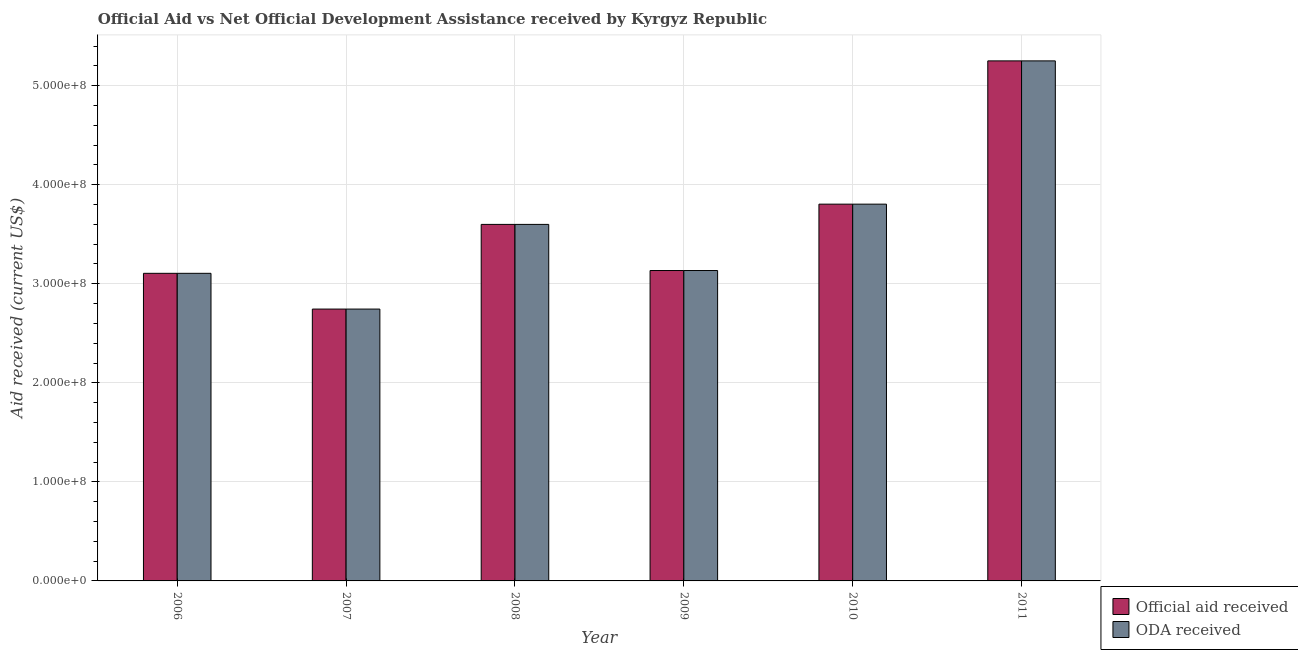Are the number of bars on each tick of the X-axis equal?
Your response must be concise. Yes. How many bars are there on the 3rd tick from the left?
Your answer should be compact. 2. What is the label of the 5th group of bars from the left?
Offer a very short reply. 2010. What is the official aid received in 2007?
Offer a terse response. 2.74e+08. Across all years, what is the maximum oda received?
Give a very brief answer. 5.25e+08. Across all years, what is the minimum oda received?
Make the answer very short. 2.74e+08. In which year was the official aid received minimum?
Make the answer very short. 2007. What is the total oda received in the graph?
Your answer should be compact. 2.16e+09. What is the difference between the oda received in 2007 and that in 2011?
Ensure brevity in your answer.  -2.51e+08. What is the difference between the oda received in 2006 and the official aid received in 2009?
Provide a short and direct response. -2.83e+06. What is the average official aid received per year?
Ensure brevity in your answer.  3.61e+08. What is the ratio of the oda received in 2009 to that in 2011?
Provide a succinct answer. 0.6. Is the oda received in 2008 less than that in 2011?
Provide a short and direct response. Yes. Is the difference between the oda received in 2008 and 2009 greater than the difference between the official aid received in 2008 and 2009?
Provide a succinct answer. No. What is the difference between the highest and the second highest oda received?
Offer a terse response. 1.45e+08. What is the difference between the highest and the lowest official aid received?
Your answer should be compact. 2.51e+08. In how many years, is the official aid received greater than the average official aid received taken over all years?
Your answer should be very brief. 2. What does the 1st bar from the left in 2007 represents?
Give a very brief answer. Official aid received. What does the 2nd bar from the right in 2011 represents?
Your answer should be compact. Official aid received. Are all the bars in the graph horizontal?
Ensure brevity in your answer.  No. How many years are there in the graph?
Give a very brief answer. 6. What is the difference between two consecutive major ticks on the Y-axis?
Your answer should be compact. 1.00e+08. Are the values on the major ticks of Y-axis written in scientific E-notation?
Your answer should be very brief. Yes. Does the graph contain any zero values?
Offer a very short reply. No. Does the graph contain grids?
Offer a very short reply. Yes. How many legend labels are there?
Provide a succinct answer. 2. How are the legend labels stacked?
Keep it short and to the point. Vertical. What is the title of the graph?
Offer a terse response. Official Aid vs Net Official Development Assistance received by Kyrgyz Republic . Does "Study and work" appear as one of the legend labels in the graph?
Ensure brevity in your answer.  No. What is the label or title of the Y-axis?
Offer a very short reply. Aid received (current US$). What is the Aid received (current US$) in Official aid received in 2006?
Provide a succinct answer. 3.11e+08. What is the Aid received (current US$) of ODA received in 2006?
Your answer should be very brief. 3.11e+08. What is the Aid received (current US$) in Official aid received in 2007?
Provide a short and direct response. 2.74e+08. What is the Aid received (current US$) of ODA received in 2007?
Give a very brief answer. 2.74e+08. What is the Aid received (current US$) of Official aid received in 2008?
Keep it short and to the point. 3.60e+08. What is the Aid received (current US$) of ODA received in 2008?
Your answer should be very brief. 3.60e+08. What is the Aid received (current US$) in Official aid received in 2009?
Ensure brevity in your answer.  3.13e+08. What is the Aid received (current US$) in ODA received in 2009?
Give a very brief answer. 3.13e+08. What is the Aid received (current US$) in Official aid received in 2010?
Offer a very short reply. 3.80e+08. What is the Aid received (current US$) of ODA received in 2010?
Give a very brief answer. 3.80e+08. What is the Aid received (current US$) in Official aid received in 2011?
Your response must be concise. 5.25e+08. What is the Aid received (current US$) in ODA received in 2011?
Provide a succinct answer. 5.25e+08. Across all years, what is the maximum Aid received (current US$) in Official aid received?
Offer a terse response. 5.25e+08. Across all years, what is the maximum Aid received (current US$) of ODA received?
Provide a succinct answer. 5.25e+08. Across all years, what is the minimum Aid received (current US$) of Official aid received?
Give a very brief answer. 2.74e+08. Across all years, what is the minimum Aid received (current US$) in ODA received?
Ensure brevity in your answer.  2.74e+08. What is the total Aid received (current US$) of Official aid received in the graph?
Offer a terse response. 2.16e+09. What is the total Aid received (current US$) of ODA received in the graph?
Provide a succinct answer. 2.16e+09. What is the difference between the Aid received (current US$) of Official aid received in 2006 and that in 2007?
Give a very brief answer. 3.61e+07. What is the difference between the Aid received (current US$) of ODA received in 2006 and that in 2007?
Your answer should be very brief. 3.61e+07. What is the difference between the Aid received (current US$) in Official aid received in 2006 and that in 2008?
Your answer should be compact. -4.94e+07. What is the difference between the Aid received (current US$) in ODA received in 2006 and that in 2008?
Ensure brevity in your answer.  -4.94e+07. What is the difference between the Aid received (current US$) in Official aid received in 2006 and that in 2009?
Make the answer very short. -2.83e+06. What is the difference between the Aid received (current US$) of ODA received in 2006 and that in 2009?
Provide a succinct answer. -2.83e+06. What is the difference between the Aid received (current US$) in Official aid received in 2006 and that in 2010?
Make the answer very short. -6.98e+07. What is the difference between the Aid received (current US$) of ODA received in 2006 and that in 2010?
Offer a very short reply. -6.98e+07. What is the difference between the Aid received (current US$) of Official aid received in 2006 and that in 2011?
Provide a succinct answer. -2.14e+08. What is the difference between the Aid received (current US$) of ODA received in 2006 and that in 2011?
Offer a terse response. -2.14e+08. What is the difference between the Aid received (current US$) of Official aid received in 2007 and that in 2008?
Ensure brevity in your answer.  -8.55e+07. What is the difference between the Aid received (current US$) of ODA received in 2007 and that in 2008?
Give a very brief answer. -8.55e+07. What is the difference between the Aid received (current US$) in Official aid received in 2007 and that in 2009?
Your response must be concise. -3.89e+07. What is the difference between the Aid received (current US$) of ODA received in 2007 and that in 2009?
Offer a terse response. -3.89e+07. What is the difference between the Aid received (current US$) of Official aid received in 2007 and that in 2010?
Your answer should be compact. -1.06e+08. What is the difference between the Aid received (current US$) in ODA received in 2007 and that in 2010?
Your answer should be very brief. -1.06e+08. What is the difference between the Aid received (current US$) in Official aid received in 2007 and that in 2011?
Offer a terse response. -2.51e+08. What is the difference between the Aid received (current US$) in ODA received in 2007 and that in 2011?
Provide a short and direct response. -2.51e+08. What is the difference between the Aid received (current US$) of Official aid received in 2008 and that in 2009?
Your answer should be very brief. 4.66e+07. What is the difference between the Aid received (current US$) of ODA received in 2008 and that in 2009?
Give a very brief answer. 4.66e+07. What is the difference between the Aid received (current US$) of Official aid received in 2008 and that in 2010?
Provide a short and direct response. -2.04e+07. What is the difference between the Aid received (current US$) of ODA received in 2008 and that in 2010?
Offer a terse response. -2.04e+07. What is the difference between the Aid received (current US$) in Official aid received in 2008 and that in 2011?
Keep it short and to the point. -1.65e+08. What is the difference between the Aid received (current US$) in ODA received in 2008 and that in 2011?
Your response must be concise. -1.65e+08. What is the difference between the Aid received (current US$) in Official aid received in 2009 and that in 2010?
Offer a very short reply. -6.70e+07. What is the difference between the Aid received (current US$) of ODA received in 2009 and that in 2010?
Your answer should be compact. -6.70e+07. What is the difference between the Aid received (current US$) in Official aid received in 2009 and that in 2011?
Give a very brief answer. -2.12e+08. What is the difference between the Aid received (current US$) of ODA received in 2009 and that in 2011?
Offer a very short reply. -2.12e+08. What is the difference between the Aid received (current US$) of Official aid received in 2010 and that in 2011?
Make the answer very short. -1.45e+08. What is the difference between the Aid received (current US$) in ODA received in 2010 and that in 2011?
Make the answer very short. -1.45e+08. What is the difference between the Aid received (current US$) of Official aid received in 2006 and the Aid received (current US$) of ODA received in 2007?
Ensure brevity in your answer.  3.61e+07. What is the difference between the Aid received (current US$) in Official aid received in 2006 and the Aid received (current US$) in ODA received in 2008?
Ensure brevity in your answer.  -4.94e+07. What is the difference between the Aid received (current US$) of Official aid received in 2006 and the Aid received (current US$) of ODA received in 2009?
Offer a very short reply. -2.83e+06. What is the difference between the Aid received (current US$) of Official aid received in 2006 and the Aid received (current US$) of ODA received in 2010?
Provide a short and direct response. -6.98e+07. What is the difference between the Aid received (current US$) of Official aid received in 2006 and the Aid received (current US$) of ODA received in 2011?
Ensure brevity in your answer.  -2.14e+08. What is the difference between the Aid received (current US$) of Official aid received in 2007 and the Aid received (current US$) of ODA received in 2008?
Offer a terse response. -8.55e+07. What is the difference between the Aid received (current US$) of Official aid received in 2007 and the Aid received (current US$) of ODA received in 2009?
Offer a terse response. -3.89e+07. What is the difference between the Aid received (current US$) in Official aid received in 2007 and the Aid received (current US$) in ODA received in 2010?
Your response must be concise. -1.06e+08. What is the difference between the Aid received (current US$) in Official aid received in 2007 and the Aid received (current US$) in ODA received in 2011?
Offer a terse response. -2.51e+08. What is the difference between the Aid received (current US$) in Official aid received in 2008 and the Aid received (current US$) in ODA received in 2009?
Offer a very short reply. 4.66e+07. What is the difference between the Aid received (current US$) in Official aid received in 2008 and the Aid received (current US$) in ODA received in 2010?
Make the answer very short. -2.04e+07. What is the difference between the Aid received (current US$) of Official aid received in 2008 and the Aid received (current US$) of ODA received in 2011?
Provide a short and direct response. -1.65e+08. What is the difference between the Aid received (current US$) of Official aid received in 2009 and the Aid received (current US$) of ODA received in 2010?
Make the answer very short. -6.70e+07. What is the difference between the Aid received (current US$) in Official aid received in 2009 and the Aid received (current US$) in ODA received in 2011?
Your answer should be very brief. -2.12e+08. What is the difference between the Aid received (current US$) in Official aid received in 2010 and the Aid received (current US$) in ODA received in 2011?
Keep it short and to the point. -1.45e+08. What is the average Aid received (current US$) of Official aid received per year?
Give a very brief answer. 3.61e+08. What is the average Aid received (current US$) of ODA received per year?
Provide a succinct answer. 3.61e+08. In the year 2010, what is the difference between the Aid received (current US$) in Official aid received and Aid received (current US$) in ODA received?
Ensure brevity in your answer.  0. In the year 2011, what is the difference between the Aid received (current US$) of Official aid received and Aid received (current US$) of ODA received?
Offer a very short reply. 0. What is the ratio of the Aid received (current US$) in Official aid received in 2006 to that in 2007?
Offer a terse response. 1.13. What is the ratio of the Aid received (current US$) in ODA received in 2006 to that in 2007?
Provide a succinct answer. 1.13. What is the ratio of the Aid received (current US$) of Official aid received in 2006 to that in 2008?
Give a very brief answer. 0.86. What is the ratio of the Aid received (current US$) in ODA received in 2006 to that in 2008?
Your answer should be very brief. 0.86. What is the ratio of the Aid received (current US$) of Official aid received in 2006 to that in 2009?
Provide a succinct answer. 0.99. What is the ratio of the Aid received (current US$) in ODA received in 2006 to that in 2009?
Your response must be concise. 0.99. What is the ratio of the Aid received (current US$) of Official aid received in 2006 to that in 2010?
Your answer should be compact. 0.82. What is the ratio of the Aid received (current US$) of ODA received in 2006 to that in 2010?
Ensure brevity in your answer.  0.82. What is the ratio of the Aid received (current US$) in Official aid received in 2006 to that in 2011?
Provide a short and direct response. 0.59. What is the ratio of the Aid received (current US$) of ODA received in 2006 to that in 2011?
Your answer should be very brief. 0.59. What is the ratio of the Aid received (current US$) of Official aid received in 2007 to that in 2008?
Your answer should be compact. 0.76. What is the ratio of the Aid received (current US$) of ODA received in 2007 to that in 2008?
Give a very brief answer. 0.76. What is the ratio of the Aid received (current US$) of Official aid received in 2007 to that in 2009?
Keep it short and to the point. 0.88. What is the ratio of the Aid received (current US$) in ODA received in 2007 to that in 2009?
Keep it short and to the point. 0.88. What is the ratio of the Aid received (current US$) in Official aid received in 2007 to that in 2010?
Your answer should be very brief. 0.72. What is the ratio of the Aid received (current US$) in ODA received in 2007 to that in 2010?
Your answer should be compact. 0.72. What is the ratio of the Aid received (current US$) of Official aid received in 2007 to that in 2011?
Offer a very short reply. 0.52. What is the ratio of the Aid received (current US$) of ODA received in 2007 to that in 2011?
Your answer should be compact. 0.52. What is the ratio of the Aid received (current US$) in Official aid received in 2008 to that in 2009?
Your answer should be compact. 1.15. What is the ratio of the Aid received (current US$) of ODA received in 2008 to that in 2009?
Offer a terse response. 1.15. What is the ratio of the Aid received (current US$) in Official aid received in 2008 to that in 2010?
Offer a terse response. 0.95. What is the ratio of the Aid received (current US$) of ODA received in 2008 to that in 2010?
Provide a succinct answer. 0.95. What is the ratio of the Aid received (current US$) in Official aid received in 2008 to that in 2011?
Offer a very short reply. 0.69. What is the ratio of the Aid received (current US$) in ODA received in 2008 to that in 2011?
Your answer should be compact. 0.69. What is the ratio of the Aid received (current US$) of Official aid received in 2009 to that in 2010?
Ensure brevity in your answer.  0.82. What is the ratio of the Aid received (current US$) of ODA received in 2009 to that in 2010?
Your answer should be very brief. 0.82. What is the ratio of the Aid received (current US$) in Official aid received in 2009 to that in 2011?
Keep it short and to the point. 0.6. What is the ratio of the Aid received (current US$) of ODA received in 2009 to that in 2011?
Provide a succinct answer. 0.6. What is the ratio of the Aid received (current US$) of Official aid received in 2010 to that in 2011?
Your answer should be very brief. 0.72. What is the ratio of the Aid received (current US$) of ODA received in 2010 to that in 2011?
Provide a short and direct response. 0.72. What is the difference between the highest and the second highest Aid received (current US$) in Official aid received?
Your answer should be very brief. 1.45e+08. What is the difference between the highest and the second highest Aid received (current US$) in ODA received?
Provide a short and direct response. 1.45e+08. What is the difference between the highest and the lowest Aid received (current US$) of Official aid received?
Provide a short and direct response. 2.51e+08. What is the difference between the highest and the lowest Aid received (current US$) in ODA received?
Your answer should be very brief. 2.51e+08. 